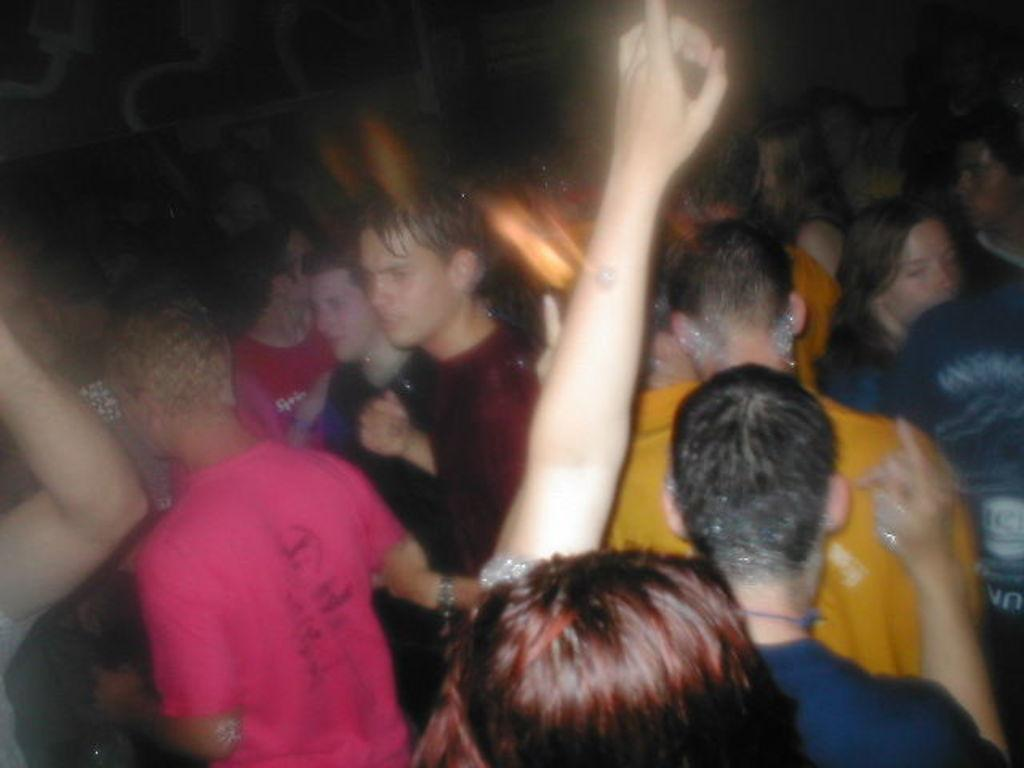How many people are in the image? There is a group of people in the image, but the exact number is not specified. What can be seen in the background of the image? The background of the image is dark. What type of skin condition is visible on the people in the image? There is no information about skin conditions in the image, and therefore no such condition can be observed. 